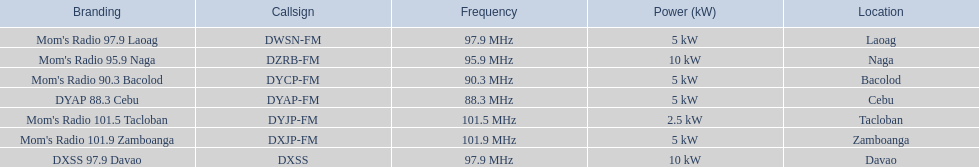Which stations use less than 10kw of power? Mom's Radio 97.9 Laoag, Mom's Radio 90.3 Bacolod, DYAP 88.3 Cebu, Mom's Radio 101.5 Tacloban, Mom's Radio 101.9 Zamboanga. Do any stations use less than 5kw of power? if so, which ones? Mom's Radio 101.5 Tacloban. 